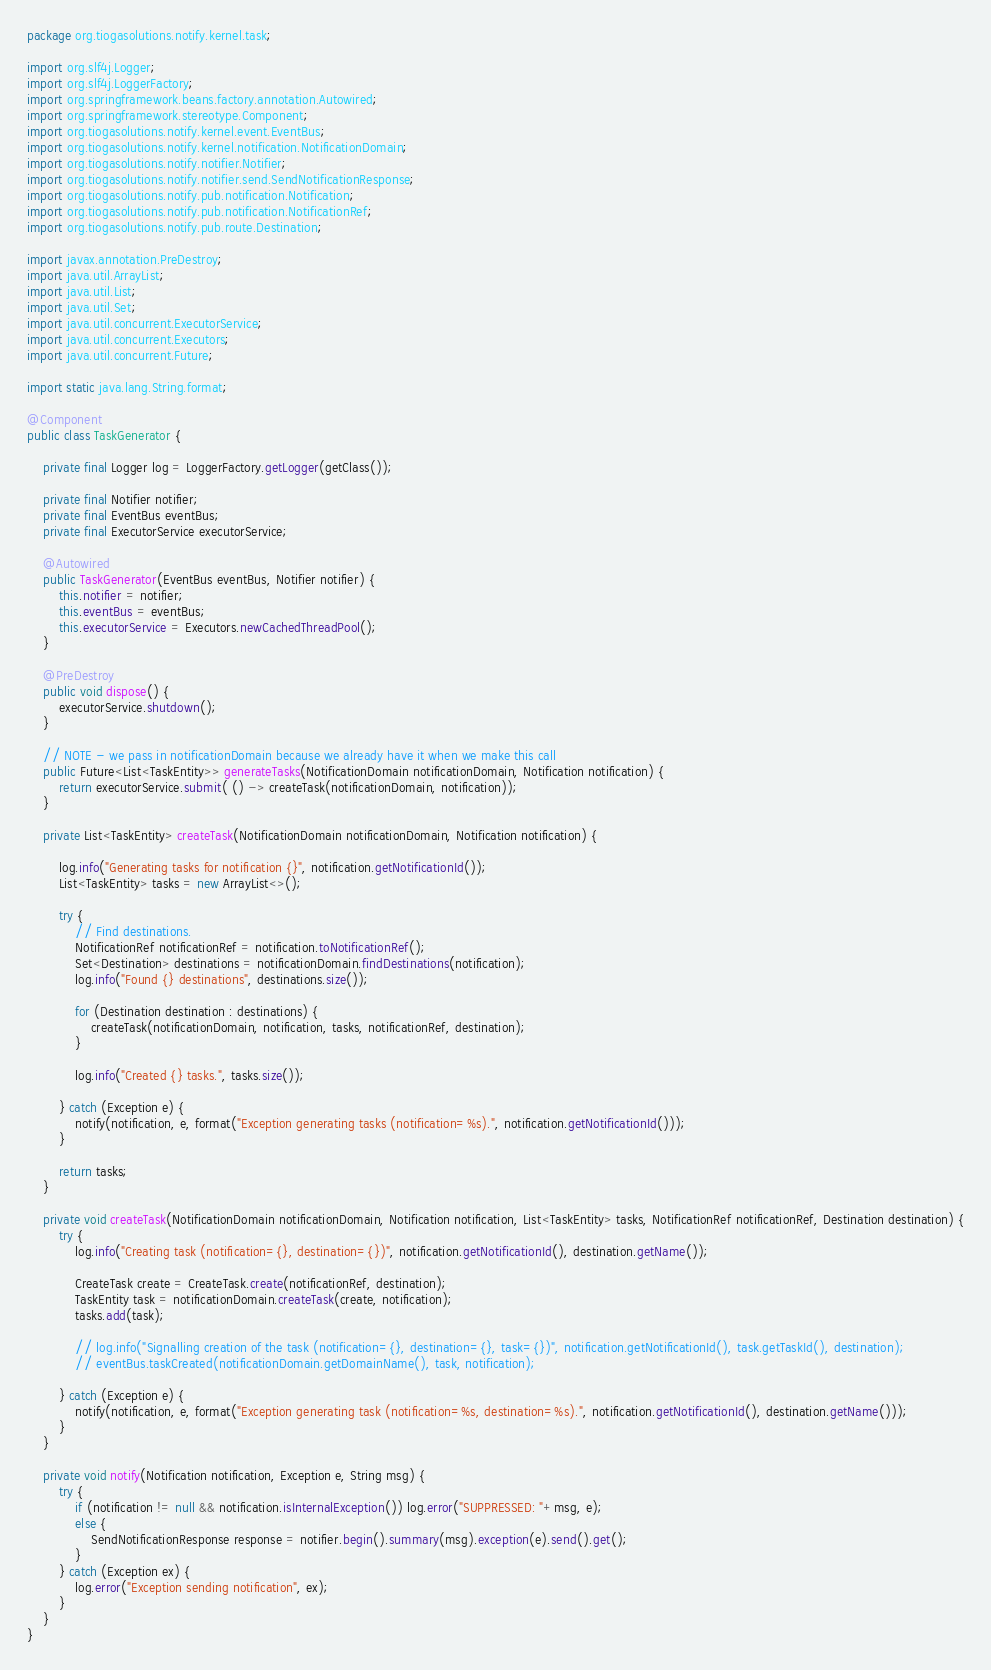Convert code to text. <code><loc_0><loc_0><loc_500><loc_500><_Java_>package org.tiogasolutions.notify.kernel.task;

import org.slf4j.Logger;
import org.slf4j.LoggerFactory;
import org.springframework.beans.factory.annotation.Autowired;
import org.springframework.stereotype.Component;
import org.tiogasolutions.notify.kernel.event.EventBus;
import org.tiogasolutions.notify.kernel.notification.NotificationDomain;
import org.tiogasolutions.notify.notifier.Notifier;
import org.tiogasolutions.notify.notifier.send.SendNotificationResponse;
import org.tiogasolutions.notify.pub.notification.Notification;
import org.tiogasolutions.notify.pub.notification.NotificationRef;
import org.tiogasolutions.notify.pub.route.Destination;

import javax.annotation.PreDestroy;
import java.util.ArrayList;
import java.util.List;
import java.util.Set;
import java.util.concurrent.ExecutorService;
import java.util.concurrent.Executors;
import java.util.concurrent.Future;

import static java.lang.String.format;

@Component
public class TaskGenerator {

    private final Logger log = LoggerFactory.getLogger(getClass());

    private final Notifier notifier;
    private final EventBus eventBus;
    private final ExecutorService executorService;

    @Autowired
    public TaskGenerator(EventBus eventBus, Notifier notifier) {
        this.notifier = notifier;
        this.eventBus = eventBus;
        this.executorService = Executors.newCachedThreadPool();
    }

    @PreDestroy
    public void dispose() {
        executorService.shutdown();
    }

    // NOTE - we pass in notificationDomain because we already have it when we make this call
    public Future<List<TaskEntity>> generateTasks(NotificationDomain notificationDomain, Notification notification) {
        return executorService.submit( () -> createTask(notificationDomain, notification));
    }

    private List<TaskEntity> createTask(NotificationDomain notificationDomain, Notification notification) {

        log.info("Generating tasks for notification {}", notification.getNotificationId());
        List<TaskEntity> tasks = new ArrayList<>();

        try {
            // Find destinations.
            NotificationRef notificationRef = notification.toNotificationRef();
            Set<Destination> destinations = notificationDomain.findDestinations(notification);
            log.info("Found {} destinations", destinations.size());

            for (Destination destination : destinations) {
                createTask(notificationDomain, notification, tasks, notificationRef, destination);
            }

            log.info("Created {} tasks.", tasks.size());

        } catch (Exception e) {
            notify(notification, e, format("Exception generating tasks (notification=%s).", notification.getNotificationId()));
        }

        return tasks;
    }

    private void createTask(NotificationDomain notificationDomain, Notification notification, List<TaskEntity> tasks, NotificationRef notificationRef, Destination destination) {
        try {
            log.info("Creating task (notification={}, destination={})", notification.getNotificationId(), destination.getName());

            CreateTask create = CreateTask.create(notificationRef, destination);
            TaskEntity task = notificationDomain.createTask(create, notification);
            tasks.add(task);

            // log.info("Signalling creation of the task (notification={}, destination={}, task={})", notification.getNotificationId(), task.getTaskId(), destination);
            // eventBus.taskCreated(notificationDomain.getDomainName(), task, notification);

        } catch (Exception e) {
            notify(notification, e, format("Exception generating task (notification=%s, destination=%s).", notification.getNotificationId(), destination.getName()));
        }
    }

    private void notify(Notification notification, Exception e, String msg) {
        try {
            if (notification != null && notification.isInternalException()) log.error("SUPPRESSED: "+msg, e);
            else {
                SendNotificationResponse response = notifier.begin().summary(msg).exception(e).send().get();
            }
        } catch (Exception ex) {
            log.error("Exception sending notification", ex);
        }
    }
}
</code> 